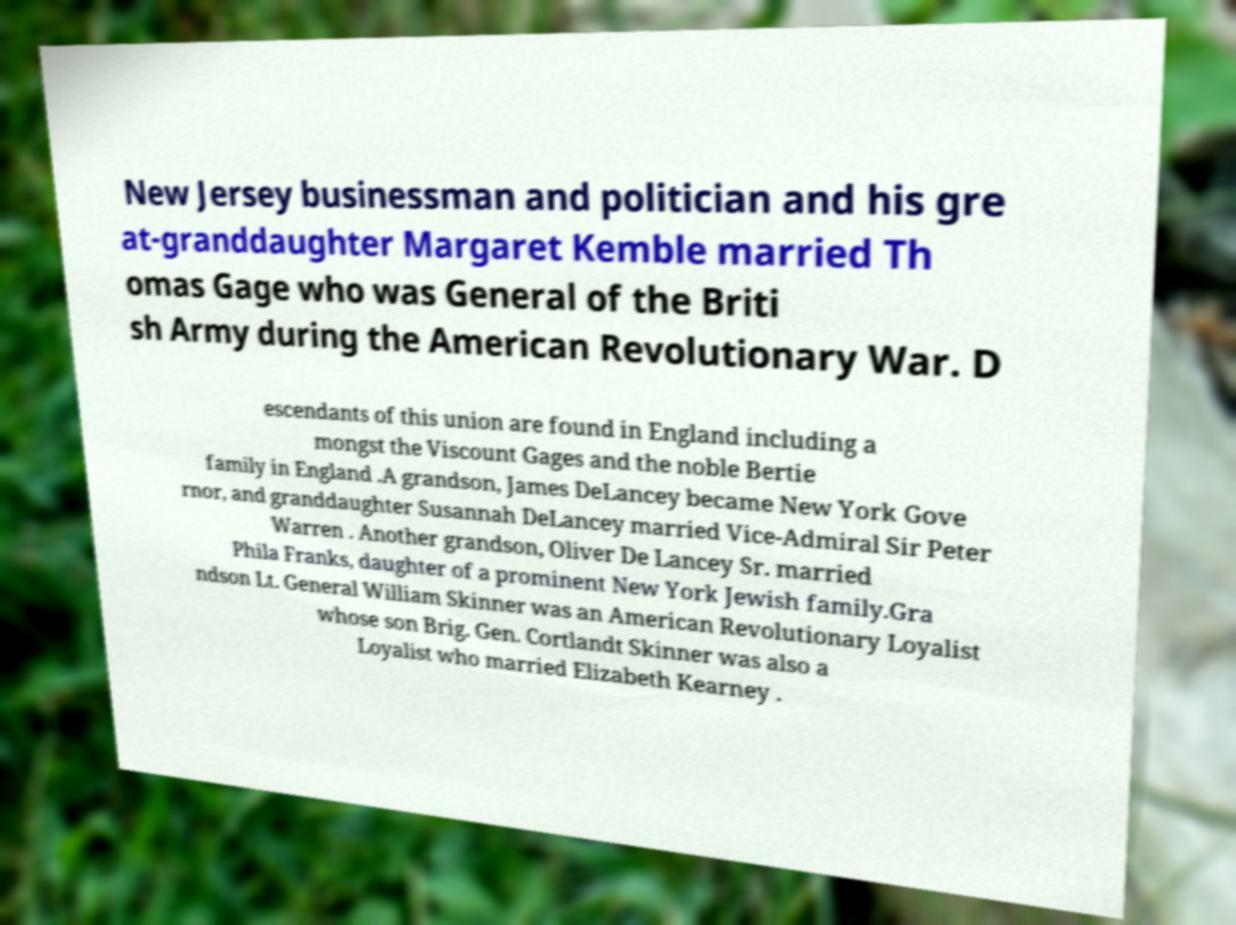I need the written content from this picture converted into text. Can you do that? New Jersey businessman and politician and his gre at-granddaughter Margaret Kemble married Th omas Gage who was General of the Briti sh Army during the American Revolutionary War. D escendants of this union are found in England including a mongst the Viscount Gages and the noble Bertie family in England .A grandson, James DeLancey became New York Gove rnor, and granddaughter Susannah DeLancey married Vice-Admiral Sir Peter Warren . Another grandson, Oliver De Lancey Sr. married Phila Franks, daughter of a prominent New York Jewish family.Gra ndson Lt. General William Skinner was an American Revolutionary Loyalist whose son Brig. Gen. Cortlandt Skinner was also a Loyalist who married Elizabeth Kearney . 